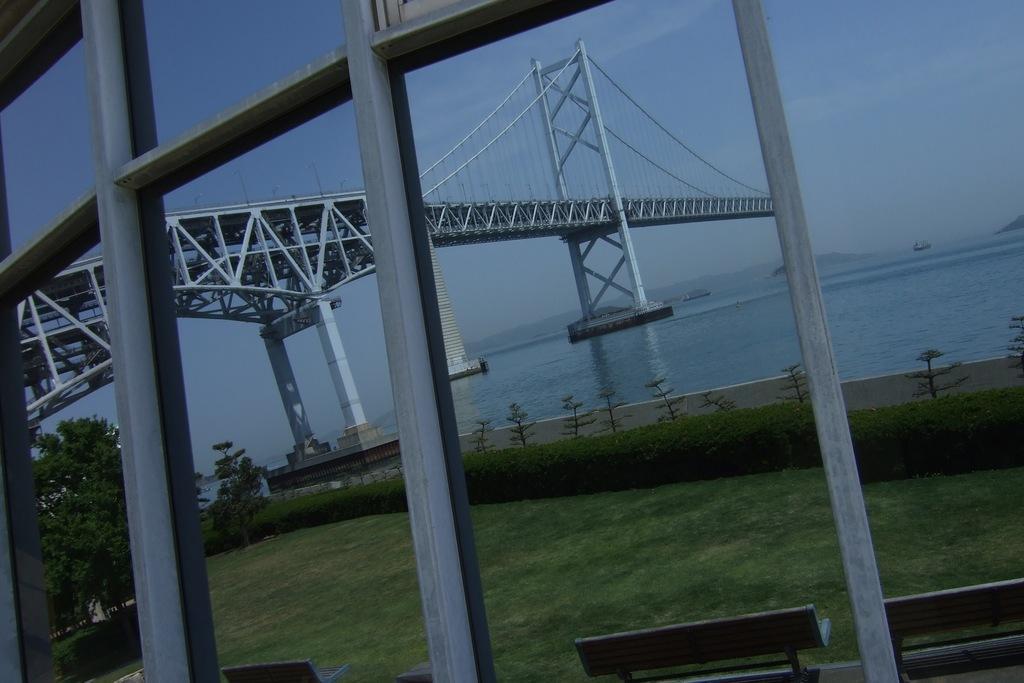Please provide a concise description of this image. In this picture we can see benches on the ground, grass, plants, trees, rods, bridge, water and in the background we can see the sky. 